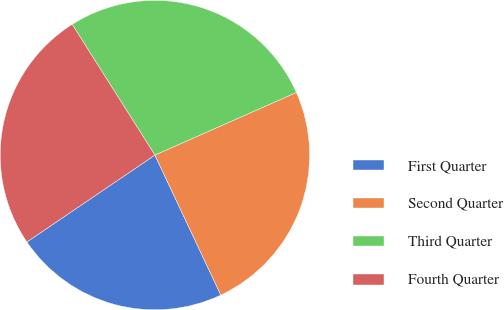Convert chart. <chart><loc_0><loc_0><loc_500><loc_500><pie_chart><fcel>First Quarter<fcel>Second Quarter<fcel>Third Quarter<fcel>Fourth Quarter<nl><fcel>22.51%<fcel>24.63%<fcel>27.35%<fcel>25.51%<nl></chart> 